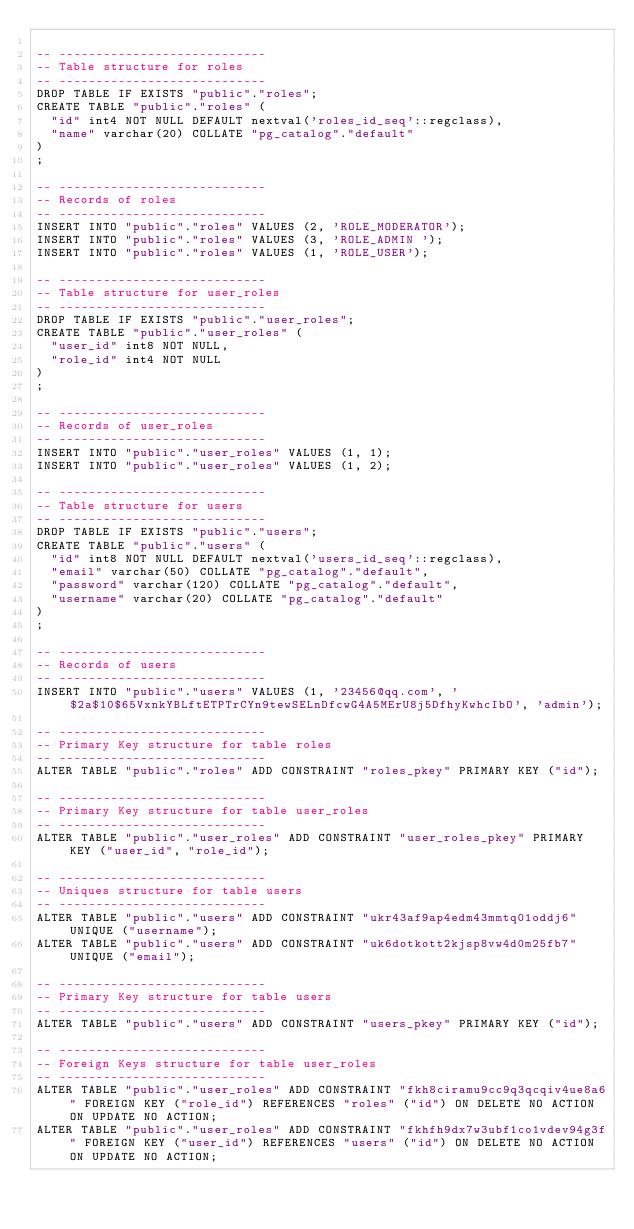<code> <loc_0><loc_0><loc_500><loc_500><_SQL_>
-- ----------------------------
-- Table structure for roles
-- ----------------------------
DROP TABLE IF EXISTS "public"."roles";
CREATE TABLE "public"."roles" (
  "id" int4 NOT NULL DEFAULT nextval('roles_id_seq'::regclass),
  "name" varchar(20) COLLATE "pg_catalog"."default"
)
;

-- ----------------------------
-- Records of roles
-- ----------------------------
INSERT INTO "public"."roles" VALUES (2, 'ROLE_MODERATOR');
INSERT INTO "public"."roles" VALUES (3, 'ROLE_ADMIN ');
INSERT INTO "public"."roles" VALUES (1, 'ROLE_USER');

-- ----------------------------
-- Table structure for user_roles
-- ----------------------------
DROP TABLE IF EXISTS "public"."user_roles";
CREATE TABLE "public"."user_roles" (
  "user_id" int8 NOT NULL,
  "role_id" int4 NOT NULL
)
;

-- ----------------------------
-- Records of user_roles
-- ----------------------------
INSERT INTO "public"."user_roles" VALUES (1, 1);
INSERT INTO "public"."user_roles" VALUES (1, 2);

-- ----------------------------
-- Table structure for users
-- ----------------------------
DROP TABLE IF EXISTS "public"."users";
CREATE TABLE "public"."users" (
  "id" int8 NOT NULL DEFAULT nextval('users_id_seq'::regclass),
  "email" varchar(50) COLLATE "pg_catalog"."default",
  "password" varchar(120) COLLATE "pg_catalog"."default",
  "username" varchar(20) COLLATE "pg_catalog"."default"
)
;

-- ----------------------------
-- Records of users
-- ----------------------------
INSERT INTO "public"."users" VALUES (1, '23456@qq.com', '$2a$10$65VxnkYBLftETPTrCYn9tewSELnDfcwG4A5MErU8j5DfhyKwhcIbO', 'admin');

-- ----------------------------
-- Primary Key structure for table roles
-- ----------------------------
ALTER TABLE "public"."roles" ADD CONSTRAINT "roles_pkey" PRIMARY KEY ("id");

-- ----------------------------
-- Primary Key structure for table user_roles
-- ----------------------------
ALTER TABLE "public"."user_roles" ADD CONSTRAINT "user_roles_pkey" PRIMARY KEY ("user_id", "role_id");

-- ----------------------------
-- Uniques structure for table users
-- ----------------------------
ALTER TABLE "public"."users" ADD CONSTRAINT "ukr43af9ap4edm43mmtq01oddj6" UNIQUE ("username");
ALTER TABLE "public"."users" ADD CONSTRAINT "uk6dotkott2kjsp8vw4d0m25fb7" UNIQUE ("email");

-- ----------------------------
-- Primary Key structure for table users
-- ----------------------------
ALTER TABLE "public"."users" ADD CONSTRAINT "users_pkey" PRIMARY KEY ("id");

-- ----------------------------
-- Foreign Keys structure for table user_roles
-- ----------------------------
ALTER TABLE "public"."user_roles" ADD CONSTRAINT "fkh8ciramu9cc9q3qcqiv4ue8a6" FOREIGN KEY ("role_id") REFERENCES "roles" ("id") ON DELETE NO ACTION ON UPDATE NO ACTION;
ALTER TABLE "public"."user_roles" ADD CONSTRAINT "fkhfh9dx7w3ubf1co1vdev94g3f" FOREIGN KEY ("user_id") REFERENCES "users" ("id") ON DELETE NO ACTION ON UPDATE NO ACTION;
</code> 